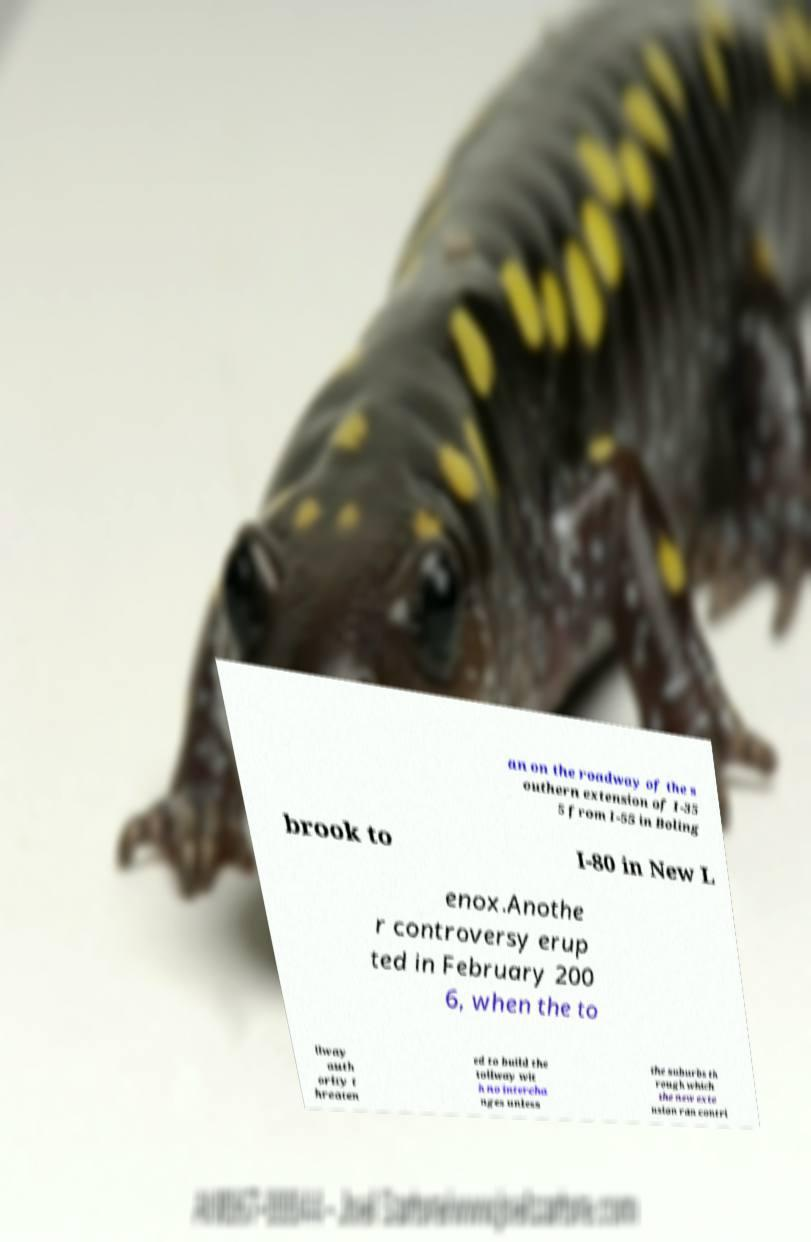I need the written content from this picture converted into text. Can you do that? an on the roadway of the s outhern extension of I-35 5 from I-55 in Boling brook to I-80 in New L enox.Anothe r controversy erup ted in February 200 6, when the to llway auth ority t hreaten ed to build the tollway wit h no intercha nges unless the suburbs th rough which the new exte nsion ran contri 